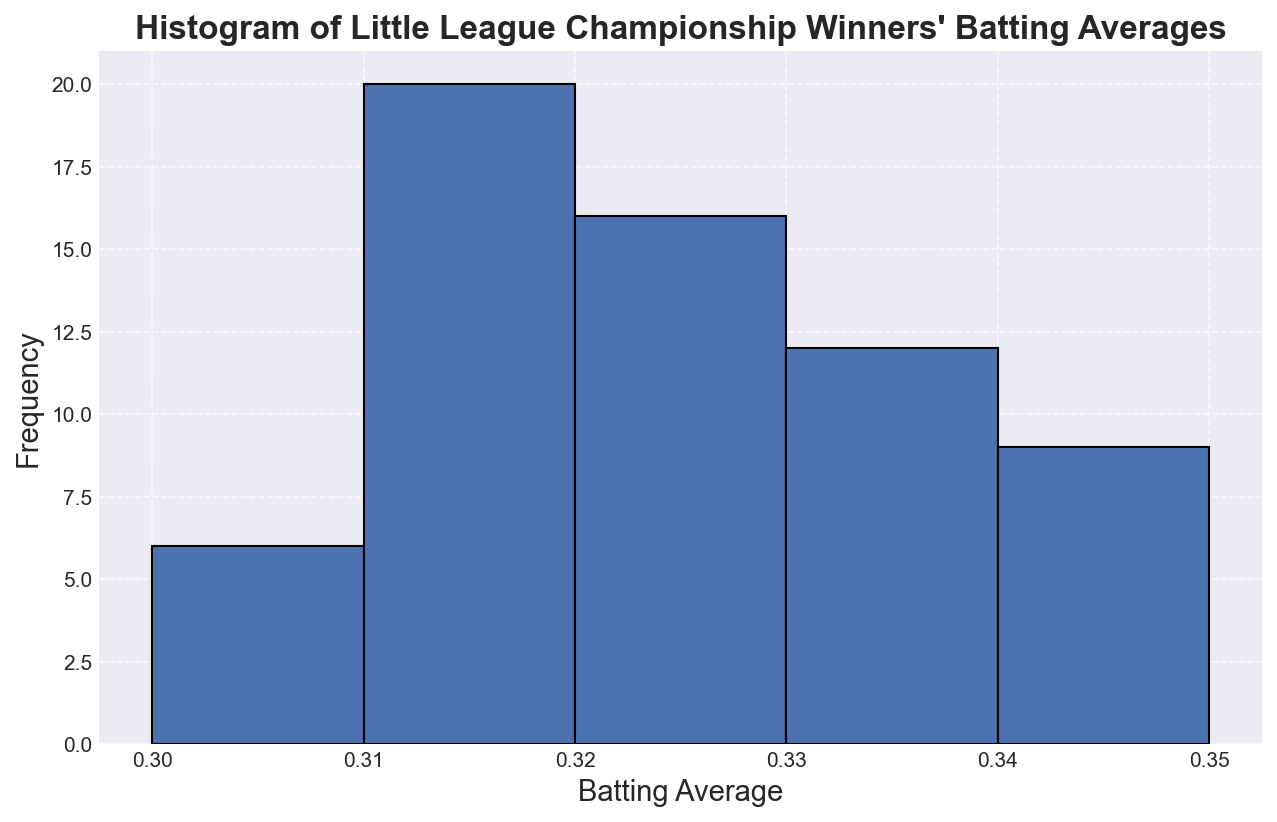What is the batting average range displayed in the histogram? The histogram bins range from 0.30 to 0.35, with a bin size of 0.01. This means the range is from 0.30 to 0.35 but includes up to 0.36.
Answer: 0.30 to 0.36 Which batting average bin has the highest frequency? The height of bars represents frequency. The bin corresponding to batting averages around 0.31 appears to have the highest bar, indicating the greatest frequency.
Answer: Around 0.31 Are there more teams with batting averages above 0.33 or below 0.33? Count the bars above 0.33 and those below 0.33. The histogram shows more bars (higher frequencies) below 0.33 than above.
Answer: Below 0.33 What's the frequency of teams with a batting average of 0.34? Check the height of the bar corresponding to the 0.34 batting average bin. This bar is relatively high, indicating a significant frequency.
Answer: High frequency (approximately 5-6 teams) Is the median batting average above or below 0.32? The histogram’s distribution shows that more bars are concentrated around 0.31. Since the distribution is slightly left-skewed, the median would likely be less than 0.32.
Answer: Below 0.32 Which batting average bins have only a single team in them? Look for the shortest bars that reach only up to one frequency; these correspond to the bins with a single team. The bins around 0.35 indicate low frequencies, potentially a single team.
Answer: Bins around 0.35 